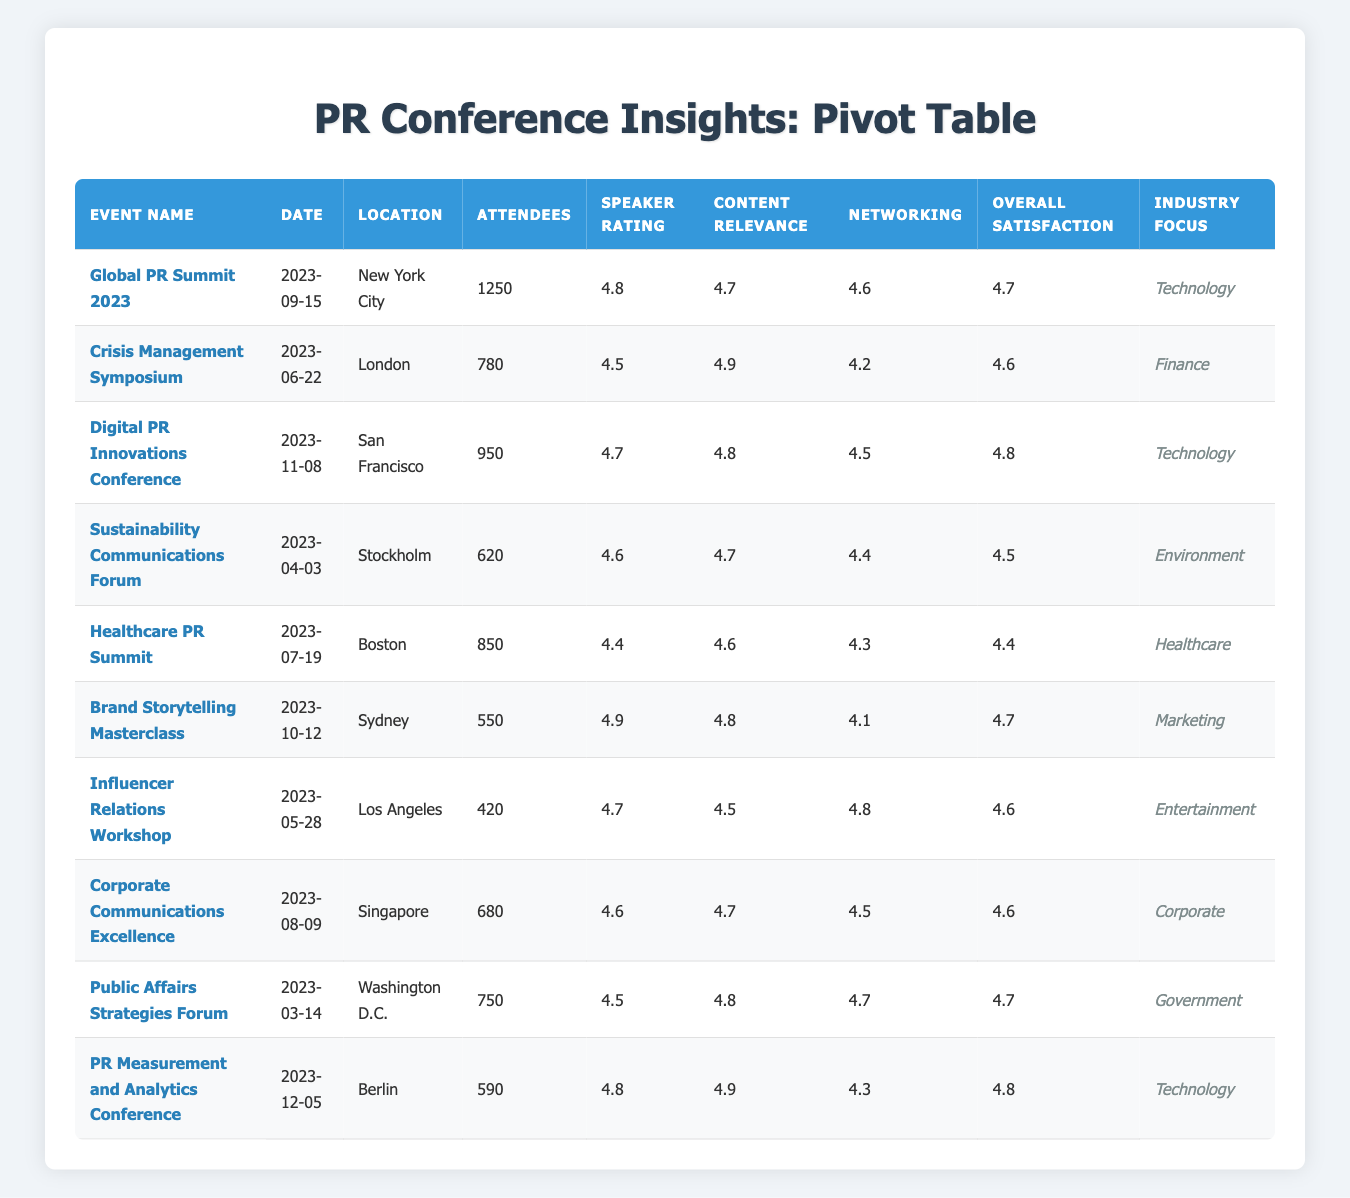What is the highest overall satisfaction rating among the events? The overall satisfaction ratings are listed as follows: 4.7 (Global PR Summit 2023), 4.6 (Crisis Management Symposium, Public Affairs Strategies Forum, Corporate Communications Excellence), 4.8 (Digital PR Innovations Conference, PR Measurement and Analytics Conference), 4.5 (Sustainability Communications Forum, Healthcare PR Summit), 4.7 (Brand Storytelling Masterclass), and 4.6 (Influencer Relations Workshop). The highest rating is 4.8 from the Digital PR Innovations Conference and PR Measurement and Analytics Conference.
Answer: 4.8 How many attendees were there at the Crisis Management Symposium? The table specifically lists the number of attendees for the Crisis Management Symposium as 780, which is found directly in its respective row.
Answer: 780 What is the average speaker rating across all events? The speaker ratings for each event are: 4.8, 4.5, 4.7, 4.6, 4.4, 4.9, 4.7, 4.6, 4.5, 4.8. Adding these ratings gives 4.8 + 4.5 + 4.7 + 4.6 + 4.4 + 4.9 + 4.7 + 4.6 + 4.5 + 4.8 = 47.5. Dividing by the total number of events (10) gives an average of 47.5 / 10 = 4.75.
Answer: 4.75 Is the average content relevance rating greater than 4.7? The content relevance ratings are: 4.7, 4.9, 4.8, 4.7, 4.6, 4.8, 4.5, 4.7, 4.8, 4.9. Summing these ratings gives 4.7 + 4.9 + 4.8 + 4.7 + 4.6 + 4.8 + 4.5 + 4.7 + 4.8 + 4.9 = 47.8. The average is 47.8 / 10 = 4.78, which is indeed greater than 4.7.
Answer: Yes Which event had the fewest attendees? The attendee counts for the events are as follows: 1250 (Global PR Summit 2023), 780 (Crisis Management Symposium), 950 (Digital PR Innovations Conference), 620 (Sustainability Communications Forum), 850 (Healthcare PR Summit), 550 (Brand Storytelling Masterclass), 420 (Influencer Relations Workshop), 680 (Corporate Communications Excellence), 750 (Public Affairs Strategies Forum), and 590 (PR Measurement and Analytics Conference). The fewest attendees, 420, is from the Influencer Relations Workshop.
Answer: 420 